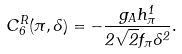<formula> <loc_0><loc_0><loc_500><loc_500>C ^ { R } _ { 6 } ( \pi , \Lambda ) = - \frac { g _ { A } h ^ { 1 } _ { \pi } } { 2 \sqrt { 2 } f _ { \pi } \Lambda ^ { 2 } } .</formula> 